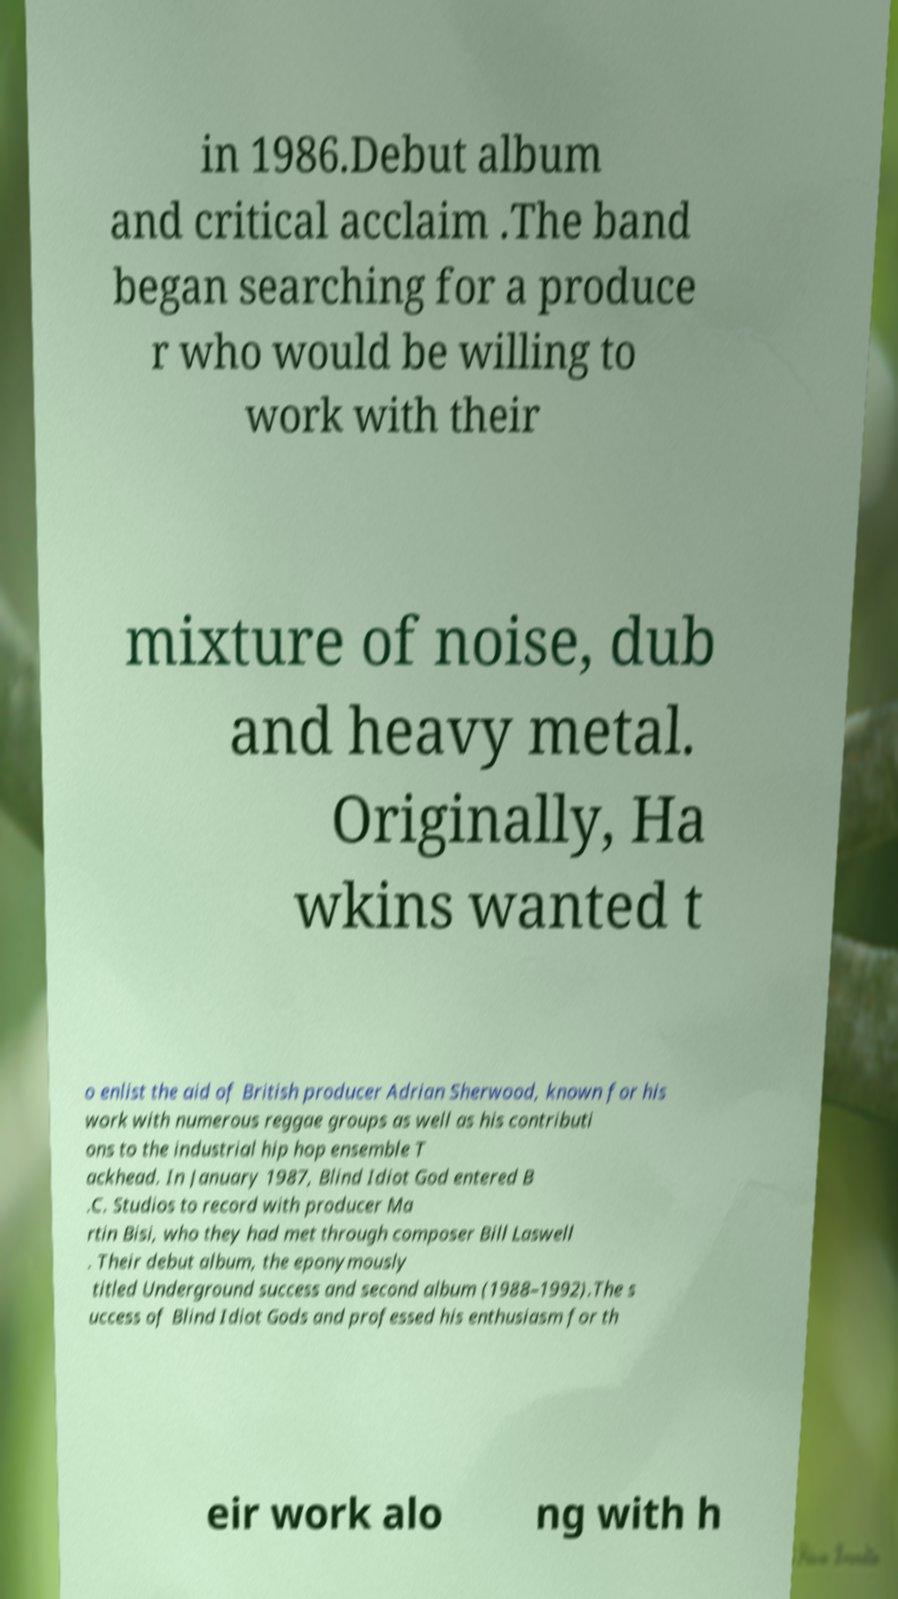I need the written content from this picture converted into text. Can you do that? in 1986.Debut album and critical acclaim .The band began searching for a produce r who would be willing to work with their mixture of noise, dub and heavy metal. Originally, Ha wkins wanted t o enlist the aid of British producer Adrian Sherwood, known for his work with numerous reggae groups as well as his contributi ons to the industrial hip hop ensemble T ackhead. In January 1987, Blind Idiot God entered B .C. Studios to record with producer Ma rtin Bisi, who they had met through composer Bill Laswell . Their debut album, the eponymously titled Underground success and second album (1988–1992).The s uccess of Blind Idiot Gods and professed his enthusiasm for th eir work alo ng with h 